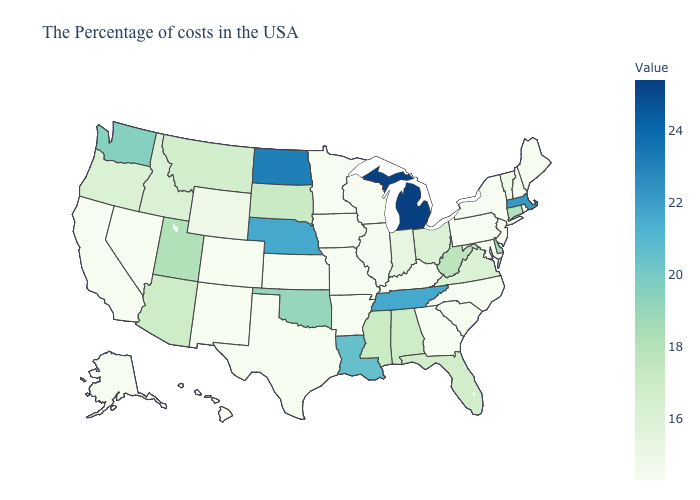Among the states that border Nebraska , which have the highest value?
Answer briefly. South Dakota. Which states have the highest value in the USA?
Write a very short answer. Michigan. Does Oregon have a higher value than Pennsylvania?
Write a very short answer. Yes. Which states have the lowest value in the USA?
Be succinct. Maine, Rhode Island, New Hampshire, New York, New Jersey, Maryland, Pennsylvania, North Carolina, South Carolina, Georgia, Kentucky, Wisconsin, Missouri, Arkansas, Minnesota, Iowa, Kansas, Texas, Colorado, New Mexico, Nevada, California, Alaska, Hawaii. Does Florida have a lower value than New Hampshire?
Quick response, please. No. Does Wisconsin have the lowest value in the MidWest?
Give a very brief answer. Yes. 